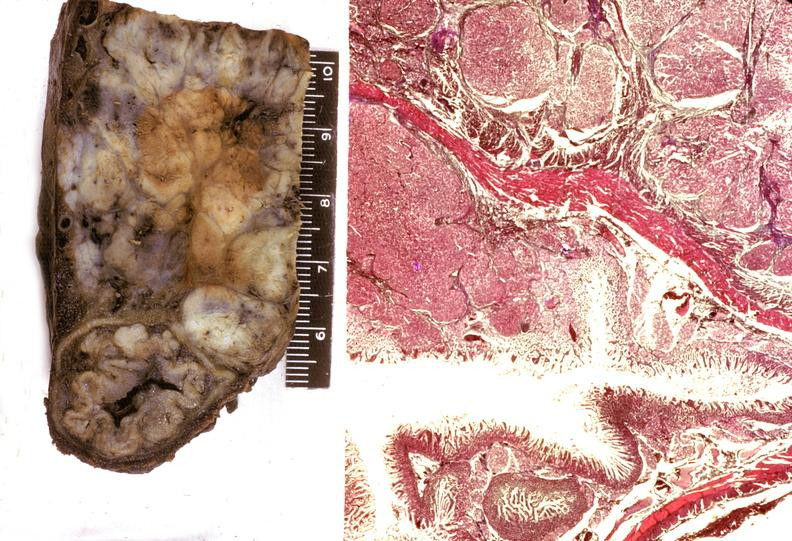does tongue show islet cell carcinoma?
Answer the question using a single word or phrase. No 